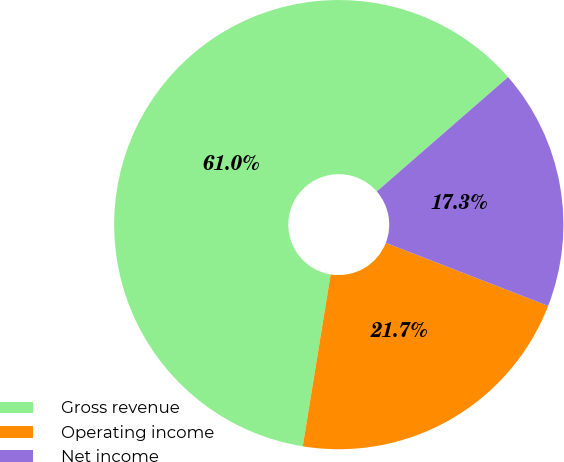Convert chart. <chart><loc_0><loc_0><loc_500><loc_500><pie_chart><fcel>Gross revenue<fcel>Operating income<fcel>Net income<nl><fcel>61.03%<fcel>21.67%<fcel>17.3%<nl></chart> 